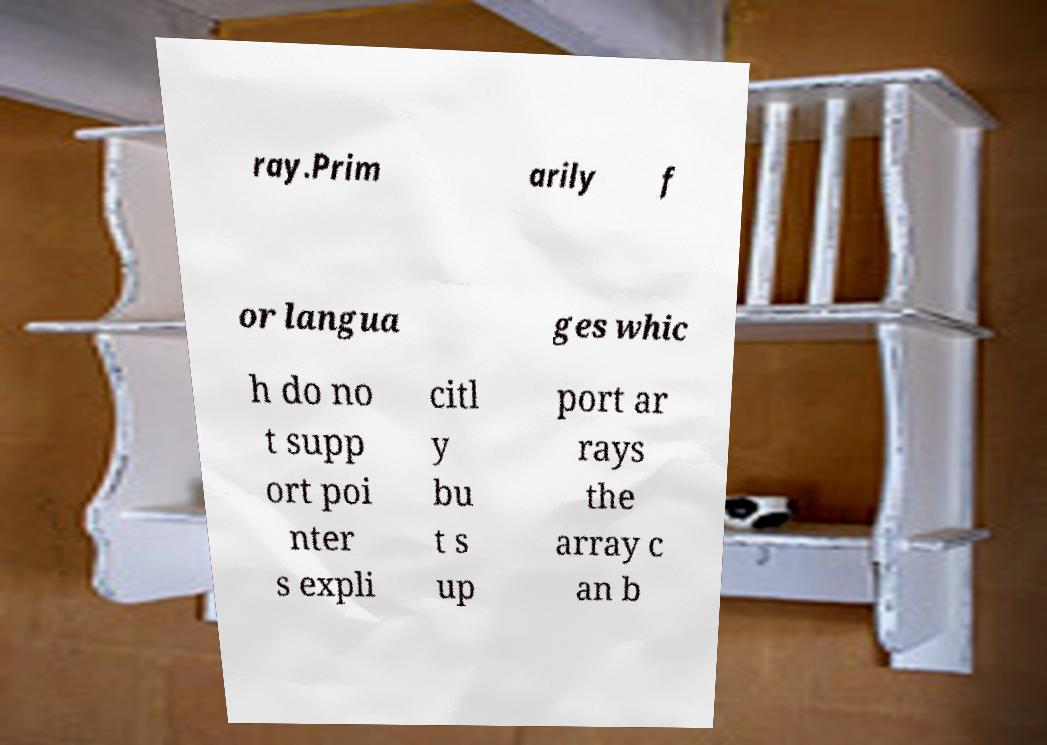Could you extract and type out the text from this image? ray.Prim arily f or langua ges whic h do no t supp ort poi nter s expli citl y bu t s up port ar rays the array c an b 